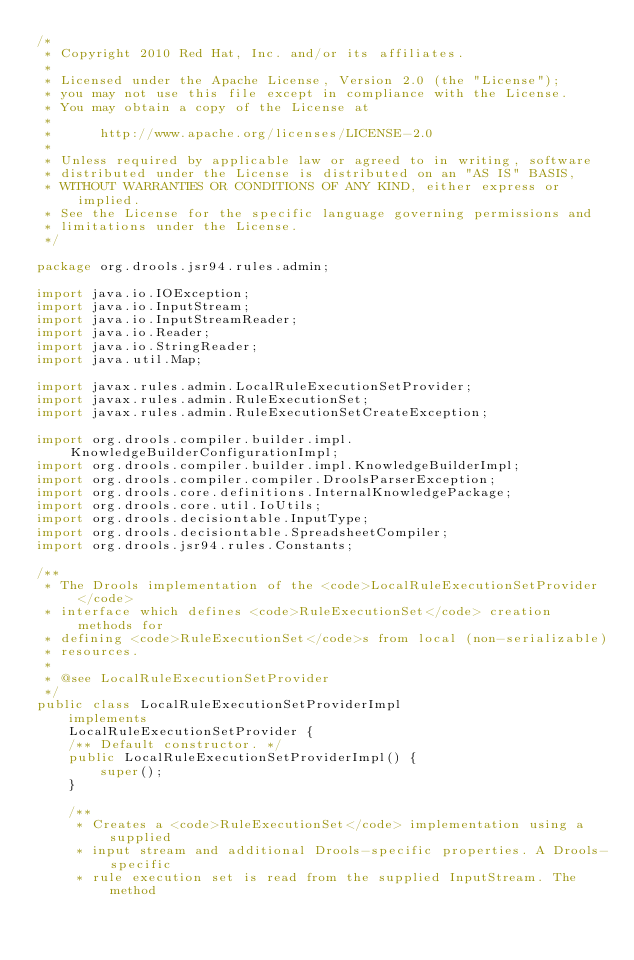Convert code to text. <code><loc_0><loc_0><loc_500><loc_500><_Java_>/*
 * Copyright 2010 Red Hat, Inc. and/or its affiliates.
 *
 * Licensed under the Apache License, Version 2.0 (the "License");
 * you may not use this file except in compliance with the License.
 * You may obtain a copy of the License at
 *
 *      http://www.apache.org/licenses/LICENSE-2.0
 *
 * Unless required by applicable law or agreed to in writing, software
 * distributed under the License is distributed on an "AS IS" BASIS,
 * WITHOUT WARRANTIES OR CONDITIONS OF ANY KIND, either express or implied.
 * See the License for the specific language governing permissions and
 * limitations under the License.
 */

package org.drools.jsr94.rules.admin;

import java.io.IOException;
import java.io.InputStream;
import java.io.InputStreamReader;
import java.io.Reader;
import java.io.StringReader;
import java.util.Map;

import javax.rules.admin.LocalRuleExecutionSetProvider;
import javax.rules.admin.RuleExecutionSet;
import javax.rules.admin.RuleExecutionSetCreateException;

import org.drools.compiler.builder.impl.KnowledgeBuilderConfigurationImpl;
import org.drools.compiler.builder.impl.KnowledgeBuilderImpl;
import org.drools.compiler.compiler.DroolsParserException;
import org.drools.core.definitions.InternalKnowledgePackage;
import org.drools.core.util.IoUtils;
import org.drools.decisiontable.InputType;
import org.drools.decisiontable.SpreadsheetCompiler;
import org.drools.jsr94.rules.Constants;

/**
 * The Drools implementation of the <code>LocalRuleExecutionSetProvider</code>
 * interface which defines <code>RuleExecutionSet</code> creation methods for
 * defining <code>RuleExecutionSet</code>s from local (non-serializable)
 * resources.
 *
 * @see LocalRuleExecutionSetProvider
 */
public class LocalRuleExecutionSetProviderImpl
    implements
    LocalRuleExecutionSetProvider {
    /** Default constructor. */
    public LocalRuleExecutionSetProviderImpl() {
        super();
    }

    /**
     * Creates a <code>RuleExecutionSet</code> implementation using a supplied
     * input stream and additional Drools-specific properties. A Drools-specific
     * rule execution set is read from the supplied InputStream. The method</code> 